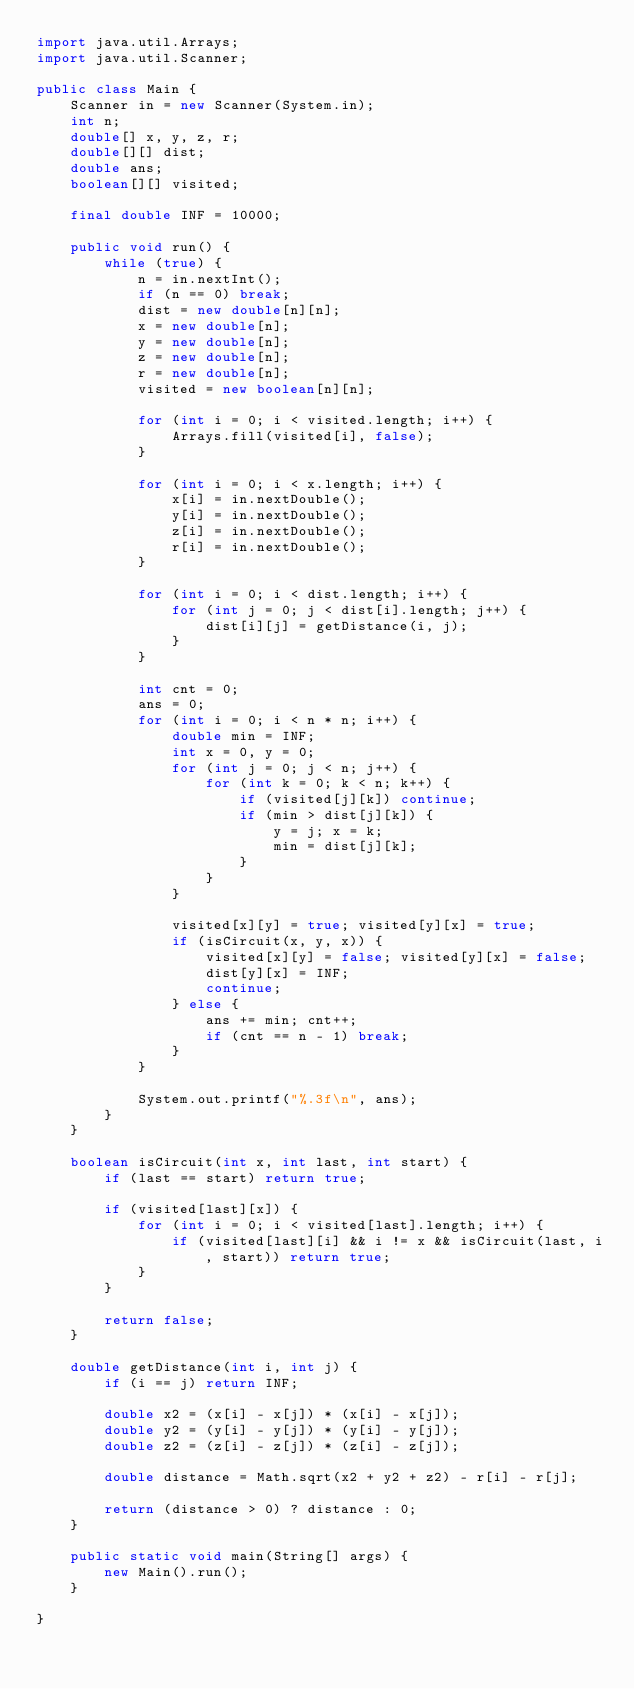<code> <loc_0><loc_0><loc_500><loc_500><_Java_>import java.util.Arrays;
import java.util.Scanner;

public class Main {
	Scanner in = new Scanner(System.in);
	int n;
	double[] x, y, z, r;
	double[][] dist;
	double ans;
	boolean[][] visited;
	
	final double INF = 10000;
	
	public void run() {
		while (true) {
			n = in.nextInt();
			if (n == 0) break;
			dist = new double[n][n];
			x = new double[n];
			y = new double[n];
			z = new double[n];
			r = new double[n];
			visited = new boolean[n][n];
			
			for (int i = 0; i < visited.length; i++) {
				Arrays.fill(visited[i], false);				
			}
			
			for (int i = 0; i < x.length; i++) {
				x[i] = in.nextDouble();
				y[i] = in.nextDouble();
				z[i] = in.nextDouble();
				r[i] = in.nextDouble();
			}
			
			for (int i = 0; i < dist.length; i++) {
				for (int j = 0; j < dist[i].length; j++) {
					dist[i][j] = getDistance(i, j);
				}
			}
			
			int cnt = 0;
			ans = 0;
			for (int i = 0; i < n * n; i++) {
				double min = INF;
				int x = 0, y = 0;
				for (int j = 0; j < n; j++) {
					for (int k = 0; k < n; k++) {
						if (visited[j][k]) continue;
						if (min > dist[j][k]) {
							y = j; x = k;
							min = dist[j][k];
						}
					}
				}

				visited[x][y] = true; visited[y][x] = true;
				if (isCircuit(x, y, x)) {
					visited[x][y] = false; visited[y][x] = false;
					dist[y][x] = INF;
					continue;
				} else {
					ans += min; cnt++;
					if (cnt == n - 1) break;
				}
			}
			
			System.out.printf("%.3f\n", ans);
		}
	}
	
	boolean isCircuit(int x, int last, int start) {
		if (last == start) return true;
		
		if (visited[last][x]) {
			for (int i = 0; i < visited[last].length; i++) {
				if (visited[last][i] && i != x && isCircuit(last, i, start)) return true;
			}
		}
		
		return false;
	}
	
	double getDistance(int i, int j) {
		if (i == j) return INF;
		
		double x2 = (x[i] - x[j]) * (x[i] - x[j]);
		double y2 = (y[i] - y[j]) * (y[i] - y[j]);
		double z2 = (z[i] - z[j]) * (z[i] - z[j]);
		
		double distance = Math.sqrt(x2 + y2 + z2) - r[i] - r[j];
		
		return (distance > 0) ? distance : 0;
	}
	
	public static void main(String[] args) {
		new Main().run();
	}

}</code> 